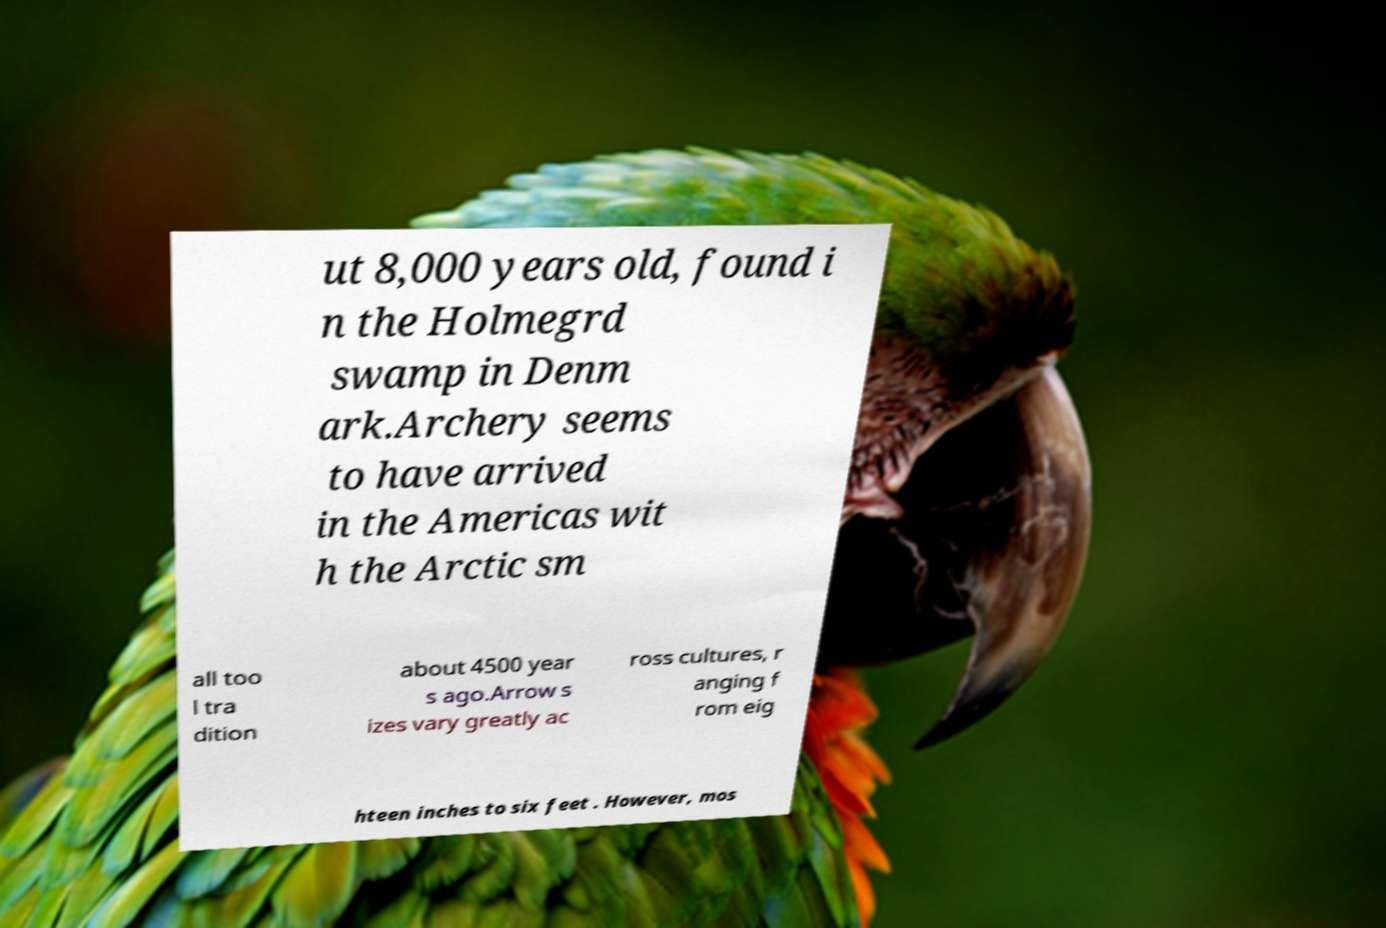What messages or text are displayed in this image? I need them in a readable, typed format. ut 8,000 years old, found i n the Holmegrd swamp in Denm ark.Archery seems to have arrived in the Americas wit h the Arctic sm all too l tra dition about 4500 year s ago.Arrow s izes vary greatly ac ross cultures, r anging f rom eig hteen inches to six feet . However, mos 